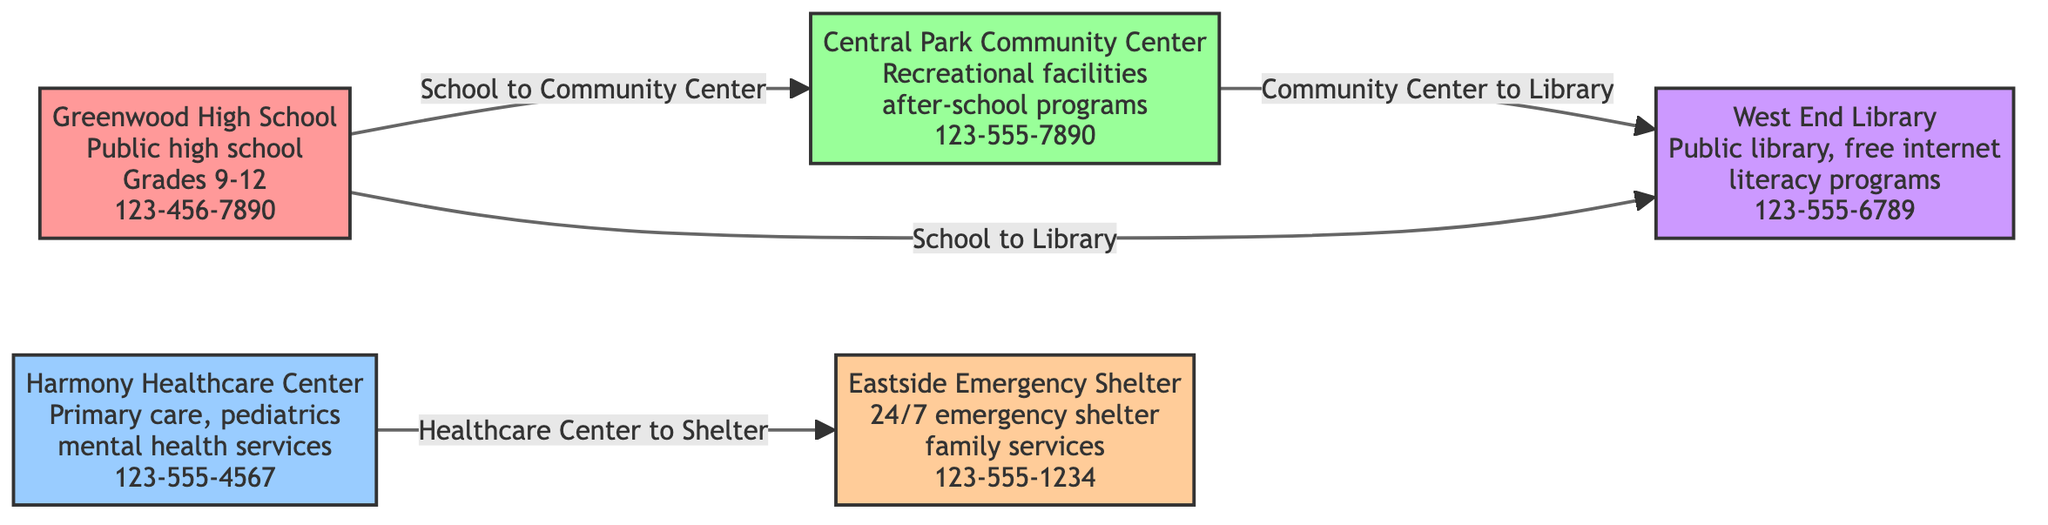What is the contact number for Greenwood High School? The contact information for Greenwood High School is listed in the diagram. It can be found within the node designated for the school, where it states the phone number is 123-456-7890.
Answer: 123-456-7890 How many different types of resources are shown in the diagram? The diagram includes five different types of resources, which are denoted by color-coded nodes: schools, healthcare centers, community centers, emergency shelters, and libraries. By counting each unique node type, we identify that there are five distinct categories.
Answer: 5 Which facility provides 24/7 emergency shelter services? The node for Eastside Emergency Shelter in the diagram specifies that it is a 24/7 emergency shelter and provides family services. This information directly shows that this facility offers the mentioned services.
Answer: Eastside Emergency Shelter What services are offered by Harmony Healthcare Center? Harmony Healthcare Center is described in the diagram with clear annotations listing services. It specifies that it provides primary care, pediatrics, and mental health services. By referring to the healthcare node, we get the complete list of offerings.
Answer: Primary care, pediatrics, mental health services Which two facilities are connected by the edge labeled "Healthcare Center to Shelter"? The label "Healthcare Center to Shelter" indicates a connection in the diagram between Harmony Healthcare Center and Eastside Emergency Shelter. By tracing the edge in the diagram, we confirm which two facilities are linked by this relationship.
Answer: Harmony Healthcare Center and Eastside Emergency Shelter Which facility is next to Central Park Community Center? The node next to Central Park Community Center can be identified by looking at the diagram's flow. The line links the community center to West End Library, indicating that the library is adjacent to the community center.
Answer: West End Library What kind of programs does Central Park Community Center offer? The node for Central Park Community Center in the diagram lists specific offerings, which include recreational facilities and after-school programs. We can directly extract this information from the community center's description.
Answer: Recreational facilities, after-school programs What is the connection between Greenwood High School and West End Library? The diagram shows a direct link from Greenwood High School to West End Library indicated by an edge labeled "School to Library." This relationship demonstrates that there is a connection between these two nodes in terms of their services or functions within the community.
Answer: School to Library How many edges connect the various facilities? To determine the number of edges, we analyze the connections shown in the diagram. There are four edges that connect the nodes (facilities) together. Counting the lines illustrated between various nodes reveals this count.
Answer: 4 